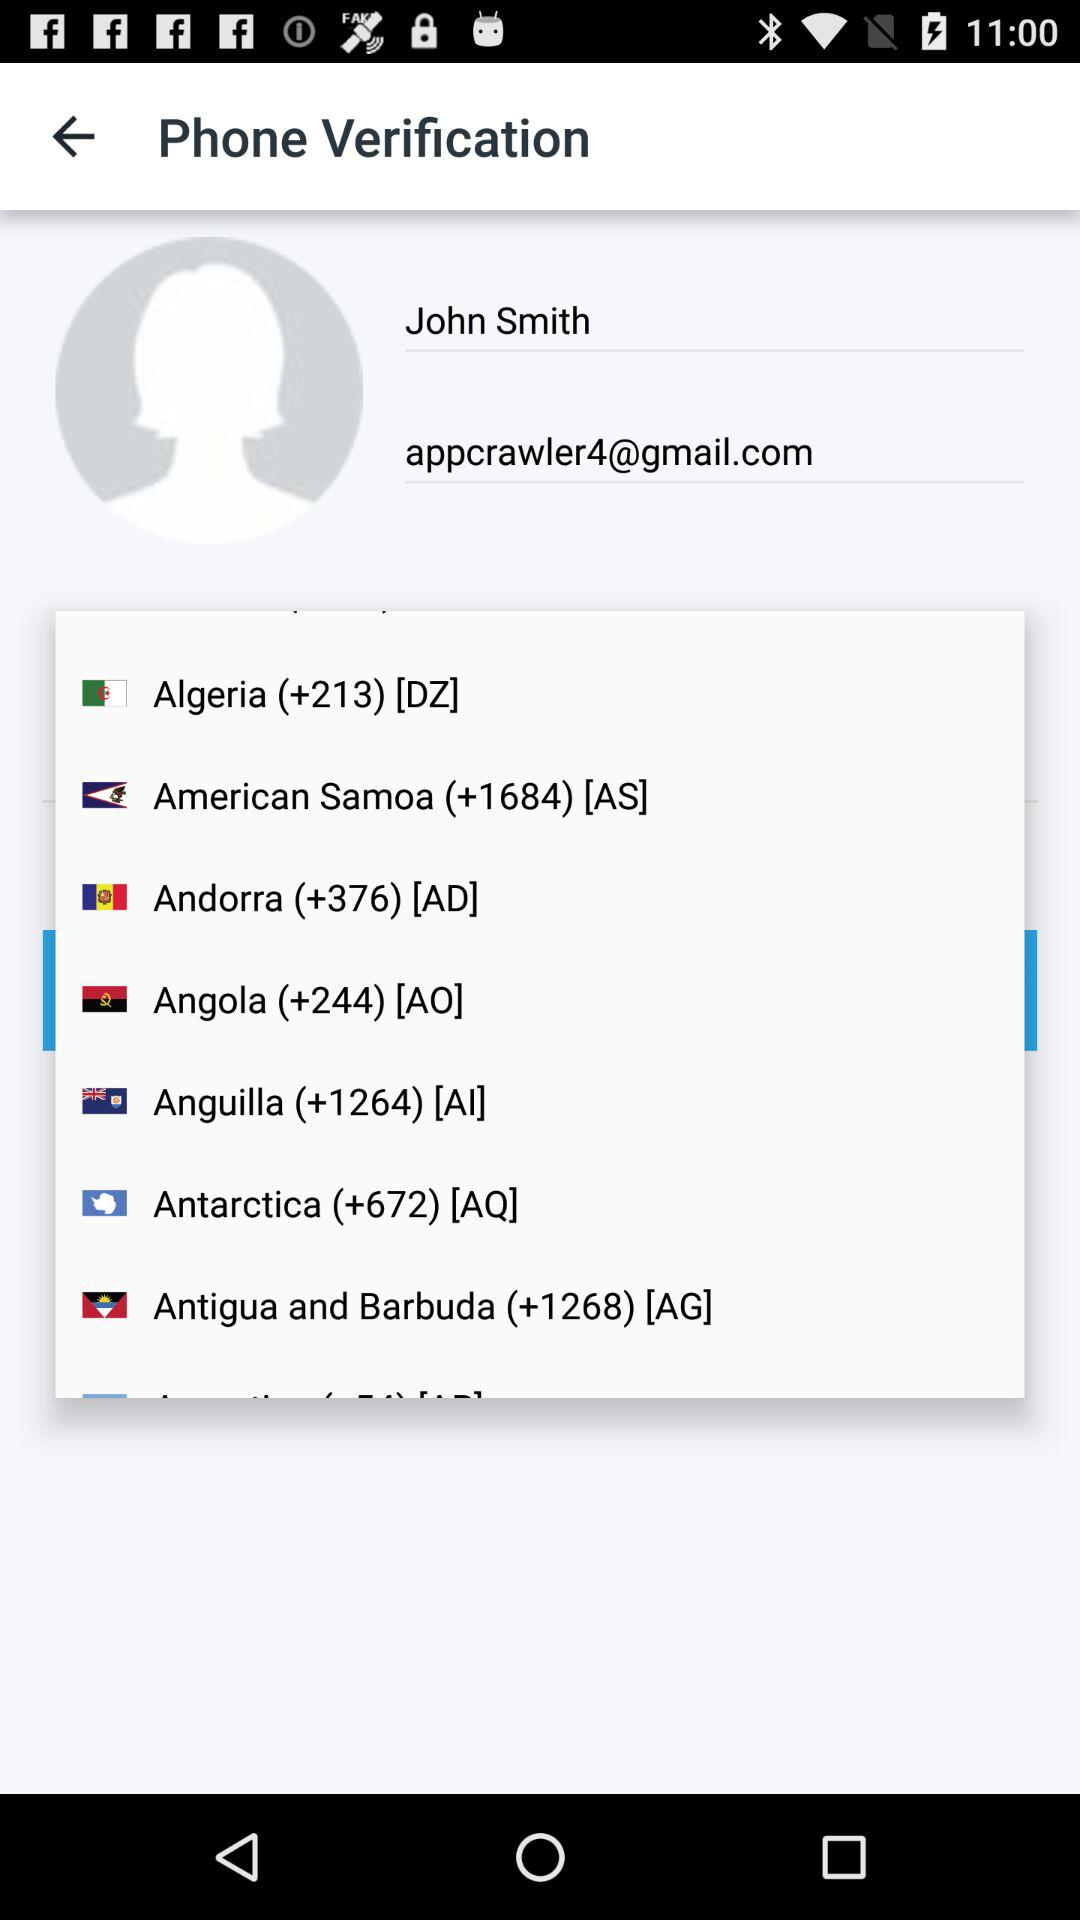What is the name of the user? The name is "John Smith". 